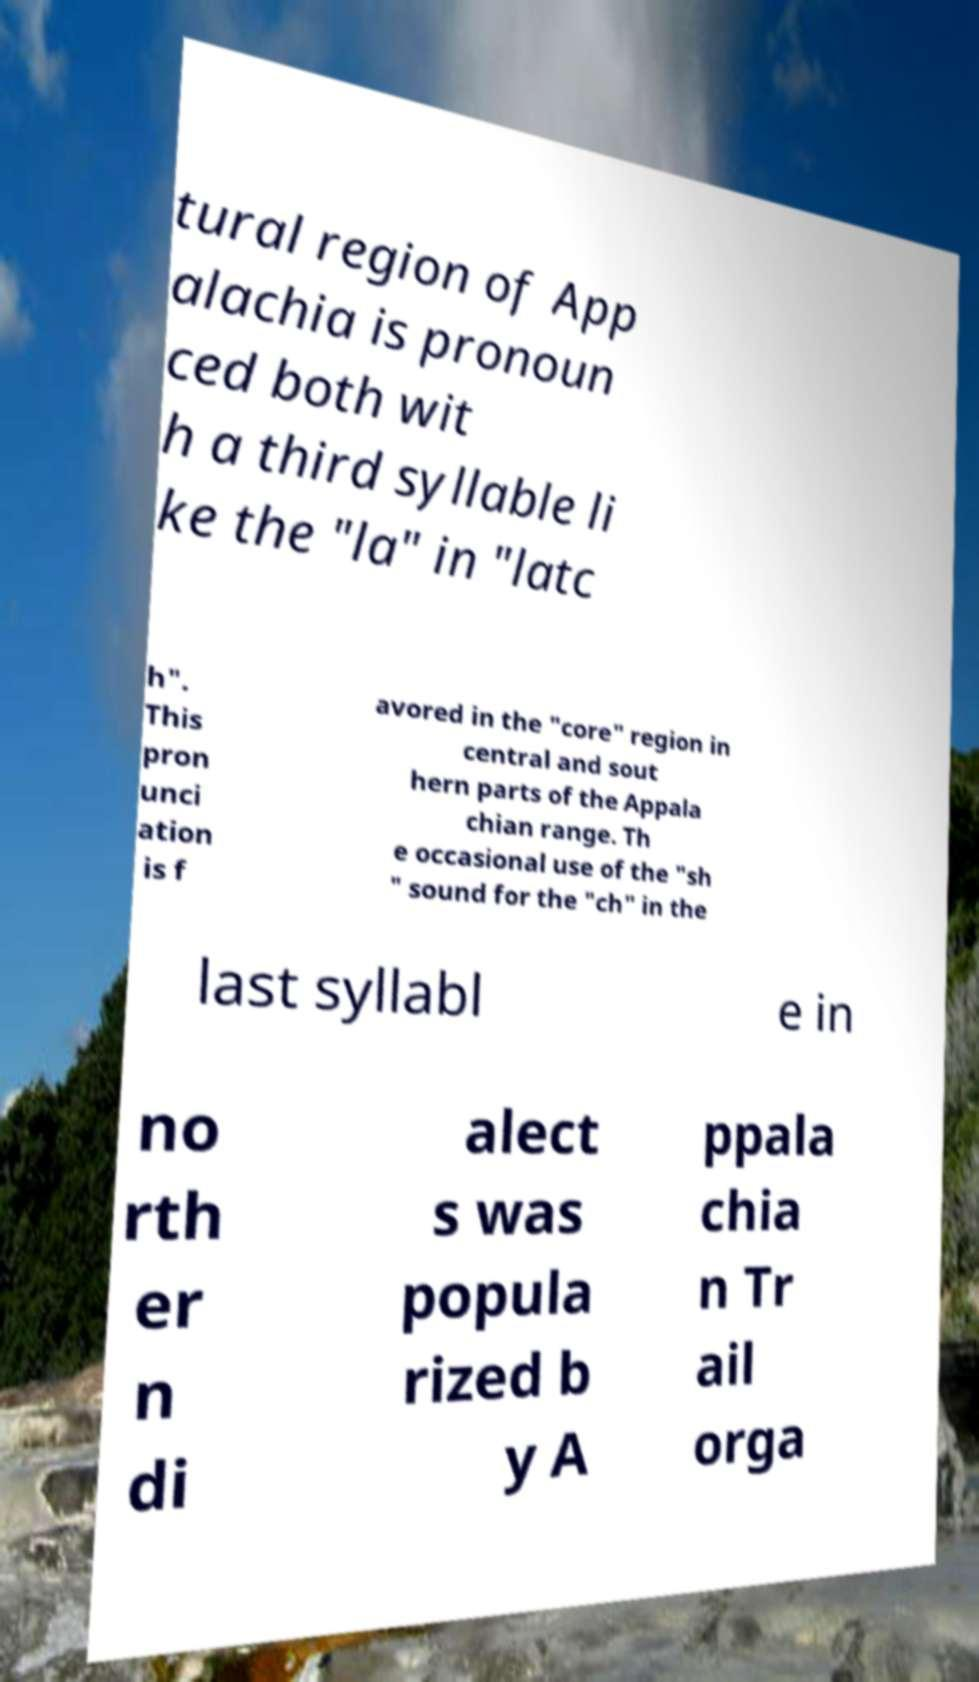Can you accurately transcribe the text from the provided image for me? tural region of App alachia is pronoun ced both wit h a third syllable li ke the "la" in "latc h". This pron unci ation is f avored in the "core" region in central and sout hern parts of the Appala chian range. Th e occasional use of the "sh " sound for the "ch" in the last syllabl e in no rth er n di alect s was popula rized b y A ppala chia n Tr ail orga 